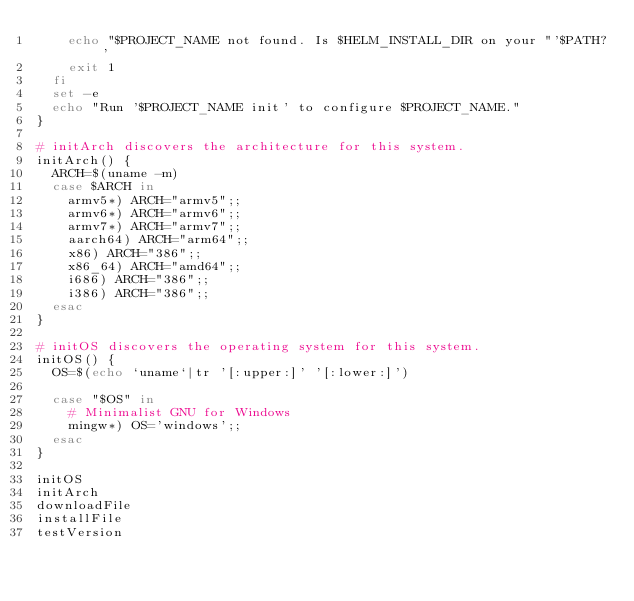Convert code to text. <code><loc_0><loc_0><loc_500><loc_500><_Bash_>    echo "$PROJECT_NAME not found. Is $HELM_INSTALL_DIR on your "'$PATH?'
    exit 1
  fi
  set -e
  echo "Run '$PROJECT_NAME init' to configure $PROJECT_NAME."
}

# initArch discovers the architecture for this system.
initArch() {
  ARCH=$(uname -m)
  case $ARCH in
    armv5*) ARCH="armv5";;
    armv6*) ARCH="armv6";;
    armv7*) ARCH="armv7";;
    aarch64) ARCH="arm64";;
    x86) ARCH="386";;
    x86_64) ARCH="amd64";;
    i686) ARCH="386";;
    i386) ARCH="386";;
  esac
}

# initOS discovers the operating system for this system.
initOS() {
  OS=$(echo `uname`|tr '[:upper:]' '[:lower:]')

  case "$OS" in
    # Minimalist GNU for Windows
    mingw*) OS='windows';;
  esac
}

initOS
initArch
downloadFile
installFile
testVersion
</code> 